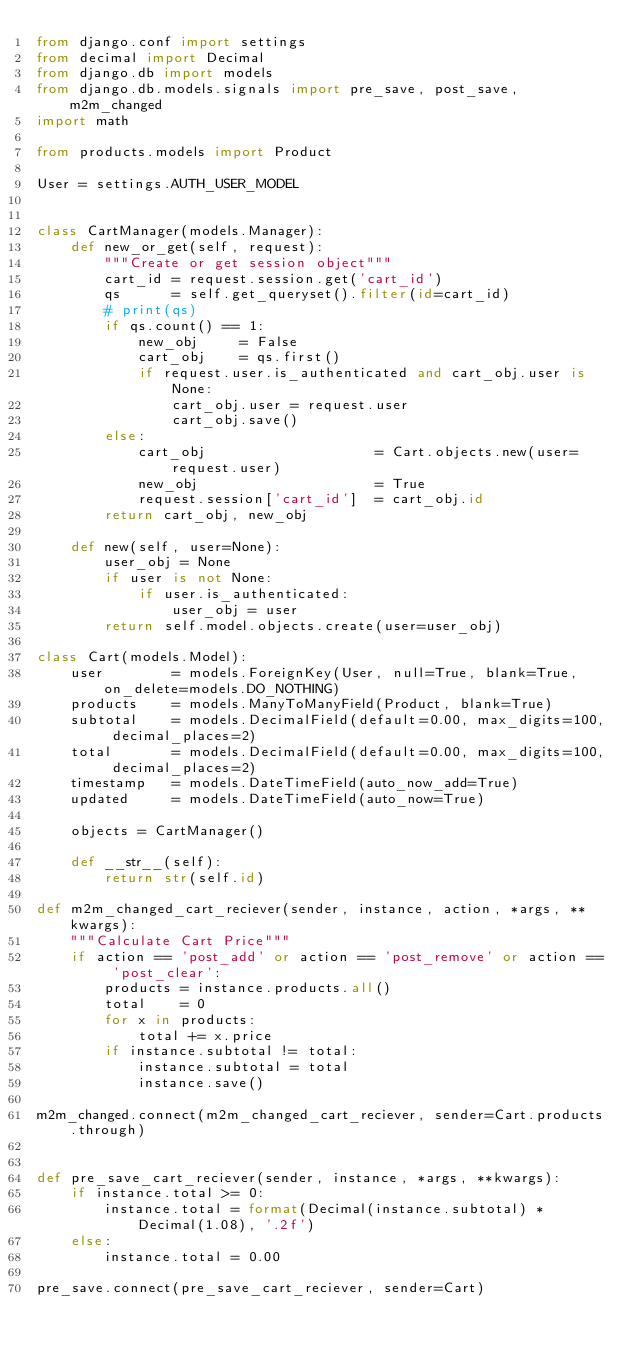<code> <loc_0><loc_0><loc_500><loc_500><_Python_>from django.conf import settings
from decimal import Decimal
from django.db import models
from django.db.models.signals import pre_save, post_save, m2m_changed
import math

from products.models import Product

User = settings.AUTH_USER_MODEL


class CartManager(models.Manager):
    def new_or_get(self, request):
        """Create or get session object"""
        cart_id = request.session.get('cart_id')
        qs      = self.get_queryset().filter(id=cart_id)
        # print(qs)
        if qs.count() == 1:
            new_obj     = False
            cart_obj    = qs.first()
            if request.user.is_authenticated and cart_obj.user is None:
                cart_obj.user = request.user
                cart_obj.save()
        else:
            cart_obj                    = Cart.objects.new(user=request.user)
            new_obj                     = True
            request.session['cart_id']  = cart_obj.id
        return cart_obj, new_obj

    def new(self, user=None):
        user_obj = None
        if user is not None:
            if user.is_authenticated:
                user_obj = user
        return self.model.objects.create(user=user_obj)

class Cart(models.Model):
    user        = models.ForeignKey(User, null=True, blank=True, on_delete=models.DO_NOTHING)
    products    = models.ManyToManyField(Product, blank=True)
    subtotal    = models.DecimalField(default=0.00, max_digits=100, decimal_places=2)
    total       = models.DecimalField(default=0.00, max_digits=100, decimal_places=2)
    timestamp   = models.DateTimeField(auto_now_add=True)
    updated     = models.DateTimeField(auto_now=True)

    objects = CartManager()

    def __str__(self):
        return str(self.id)

def m2m_changed_cart_reciever(sender, instance, action, *args, **kwargs):
    """Calculate Cart Price"""
    if action == 'post_add' or action == 'post_remove' or action == 'post_clear':
        products = instance.products.all()
        total    = 0
        for x in products:
            total += x.price
        if instance.subtotal != total:
            instance.subtotal = total
            instance.save()

m2m_changed.connect(m2m_changed_cart_reciever, sender=Cart.products.through)


def pre_save_cart_reciever(sender, instance, *args, **kwargs):
    if instance.total >= 0:
        instance.total = format(Decimal(instance.subtotal) * Decimal(1.08), '.2f')
    else:
        instance.total = 0.00

pre_save.connect(pre_save_cart_reciever, sender=Cart)
</code> 